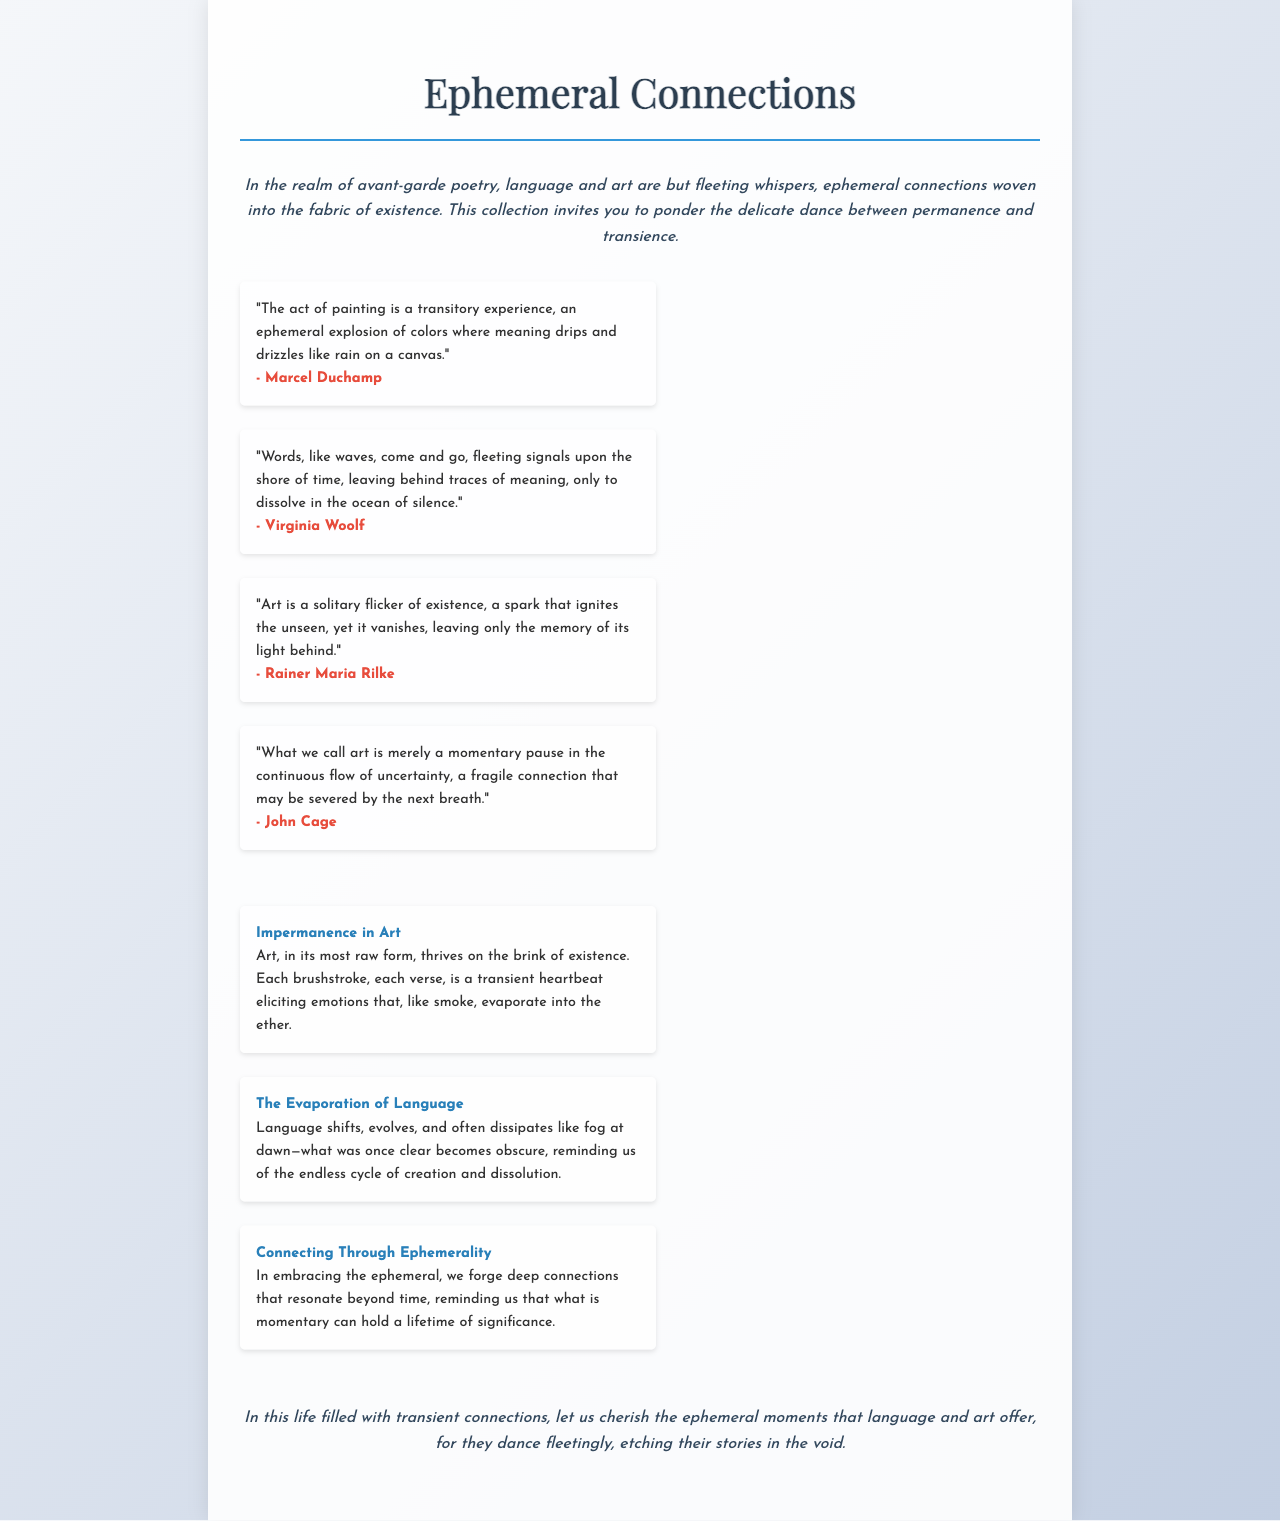what is the title of the document? The title of the document is presented prominently at the top of the brochure.
Answer: Ephemeral Connections who is the author of the quote about painting? The author of the quote regarding painting is mentioned directly below the quote.
Answer: Marcel Duchamp how many quotes are included in the document? The number of quotes is determined by counting each listed quote within the document.
Answer: Four what theme is explored in the second thought? The theme is clearly stated as a heading in each thought section.
Answer: The Evaporation of Language what color is used for the background of the brochure? The background color can be inferred from the CSS styles applied in the document.
Answer: Gradient what does art represent according to John Cage's quote? The essence of art can be gathered from the description within his quote in the document.
Answer: Momentary pause how does the document describe language? The document contains an explicit description regarding language in one of the thought sections.
Answer: Shifts and evolves what is the significance of ephemeral connections according to the conclusion? The conclusion encapsulates the significance of ephemeral moments in language and art.
Answer: Cherish them 